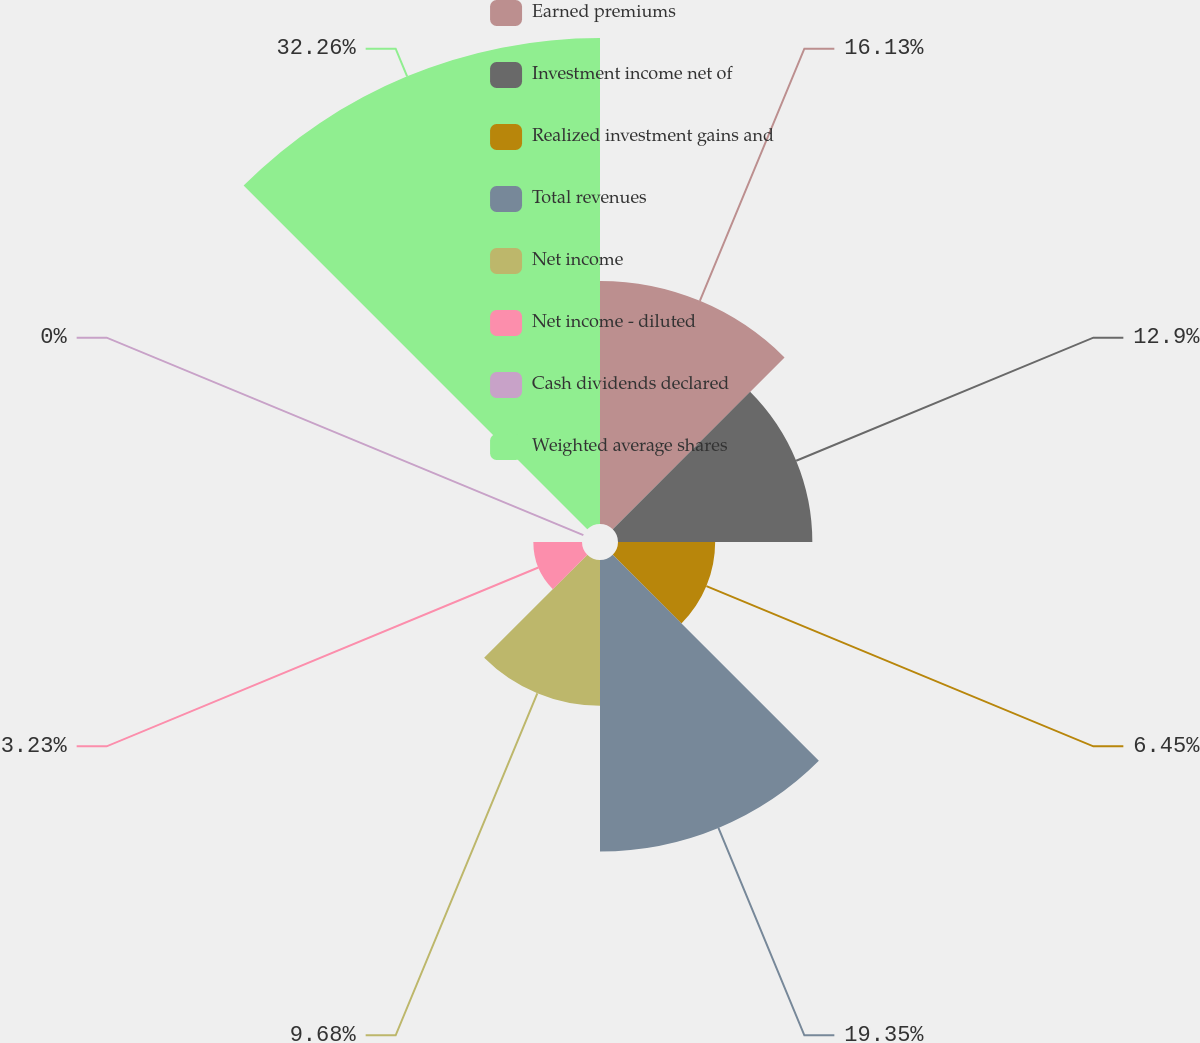<chart> <loc_0><loc_0><loc_500><loc_500><pie_chart><fcel>Earned premiums<fcel>Investment income net of<fcel>Realized investment gains and<fcel>Total revenues<fcel>Net income<fcel>Net income - diluted<fcel>Cash dividends declared<fcel>Weighted average shares<nl><fcel>16.13%<fcel>12.9%<fcel>6.45%<fcel>19.35%<fcel>9.68%<fcel>3.23%<fcel>0.0%<fcel>32.26%<nl></chart> 